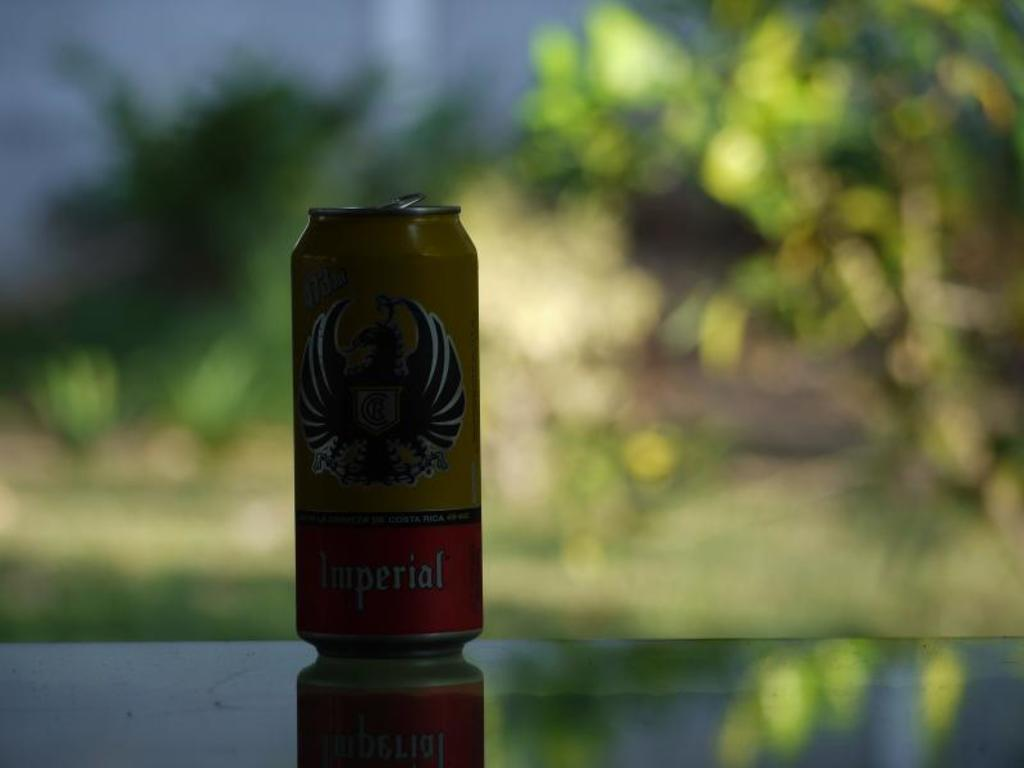What is on the glass in the image? There is a cock-ring on the glass. What can be seen in the distance behind the glass? Trees are visible in the background. How is the background of the image depicted? The background is blurred. What type of leather is used to make the place in the image? There is no place or leather present in the image; it features a cock-ring on a glass with trees in the background. 